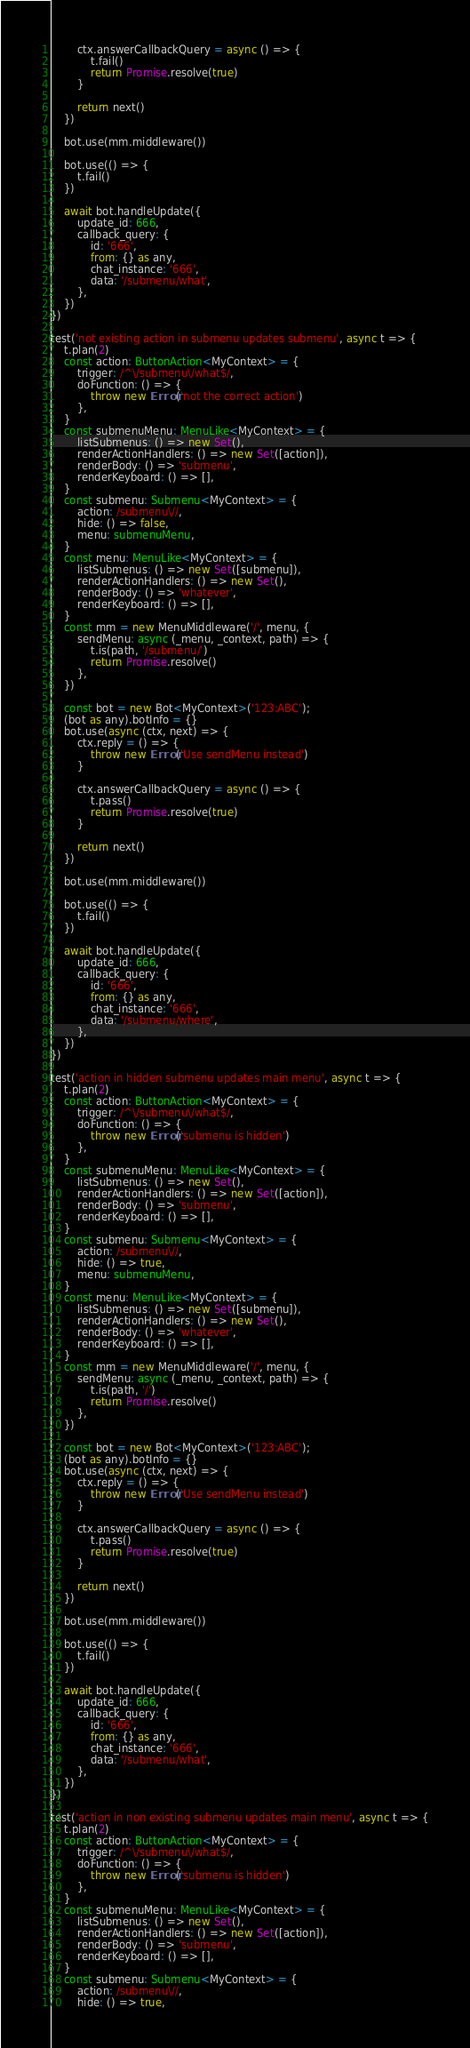<code> <loc_0><loc_0><loc_500><loc_500><_TypeScript_>
		ctx.answerCallbackQuery = async () => {
			t.fail()
			return Promise.resolve(true)
		}

		return next()
	})

	bot.use(mm.middleware())

	bot.use(() => {
		t.fail()
	})

	await bot.handleUpdate({
		update_id: 666,
		callback_query: {
			id: '666',
			from: {} as any,
			chat_instance: '666',
			data: '/submenu/what',
		},
	})
})

test('not existing action in submenu updates submenu', async t => {
	t.plan(2)
	const action: ButtonAction<MyContext> = {
		trigger: /^\/submenu\/what$/,
		doFunction: () => {
			throw new Error('not the correct action')
		},
	}
	const submenuMenu: MenuLike<MyContext> = {
		listSubmenus: () => new Set(),
		renderActionHandlers: () => new Set([action]),
		renderBody: () => 'submenu',
		renderKeyboard: () => [],
	}
	const submenu: Submenu<MyContext> = {
		action: /submenu\//,
		hide: () => false,
		menu: submenuMenu,
	}
	const menu: MenuLike<MyContext> = {
		listSubmenus: () => new Set([submenu]),
		renderActionHandlers: () => new Set(),
		renderBody: () => 'whatever',
		renderKeyboard: () => [],
	}
	const mm = new MenuMiddleware('/', menu, {
		sendMenu: async (_menu, _context, path) => {
			t.is(path, '/submenu/')
			return Promise.resolve()
		},
	})

	const bot = new Bot<MyContext>('123:ABC');
	(bot as any).botInfo = {}
	bot.use(async (ctx, next) => {
		ctx.reply = () => {
			throw new Error('Use sendMenu instead')
		}

		ctx.answerCallbackQuery = async () => {
			t.pass()
			return Promise.resolve(true)
		}

		return next()
	})

	bot.use(mm.middleware())

	bot.use(() => {
		t.fail()
	})

	await bot.handleUpdate({
		update_id: 666,
		callback_query: {
			id: '666',
			from: {} as any,
			chat_instance: '666',
			data: '/submenu/where',
		},
	})
})

test('action in hidden submenu updates main menu', async t => {
	t.plan(2)
	const action: ButtonAction<MyContext> = {
		trigger: /^\/submenu\/what$/,
		doFunction: () => {
			throw new Error('submenu is hidden')
		},
	}
	const submenuMenu: MenuLike<MyContext> = {
		listSubmenus: () => new Set(),
		renderActionHandlers: () => new Set([action]),
		renderBody: () => 'submenu',
		renderKeyboard: () => [],
	}
	const submenu: Submenu<MyContext> = {
		action: /submenu\//,
		hide: () => true,
		menu: submenuMenu,
	}
	const menu: MenuLike<MyContext> = {
		listSubmenus: () => new Set([submenu]),
		renderActionHandlers: () => new Set(),
		renderBody: () => 'whatever',
		renderKeyboard: () => [],
	}
	const mm = new MenuMiddleware('/', menu, {
		sendMenu: async (_menu, _context, path) => {
			t.is(path, '/')
			return Promise.resolve()
		},
	})

	const bot = new Bot<MyContext>('123:ABC');
	(bot as any).botInfo = {}
	bot.use(async (ctx, next) => {
		ctx.reply = () => {
			throw new Error('Use sendMenu instead')
		}

		ctx.answerCallbackQuery = async () => {
			t.pass()
			return Promise.resolve(true)
		}

		return next()
	})

	bot.use(mm.middleware())

	bot.use(() => {
		t.fail()
	})

	await bot.handleUpdate({
		update_id: 666,
		callback_query: {
			id: '666',
			from: {} as any,
			chat_instance: '666',
			data: '/submenu/what',
		},
	})
})

test('action in non existing submenu updates main menu', async t => {
	t.plan(2)
	const action: ButtonAction<MyContext> = {
		trigger: /^\/submenu\/what$/,
		doFunction: () => {
			throw new Error('submenu is hidden')
		},
	}
	const submenuMenu: MenuLike<MyContext> = {
		listSubmenus: () => new Set(),
		renderActionHandlers: () => new Set([action]),
		renderBody: () => 'submenu',
		renderKeyboard: () => [],
	}
	const submenu: Submenu<MyContext> = {
		action: /submenu\//,
		hide: () => true,</code> 